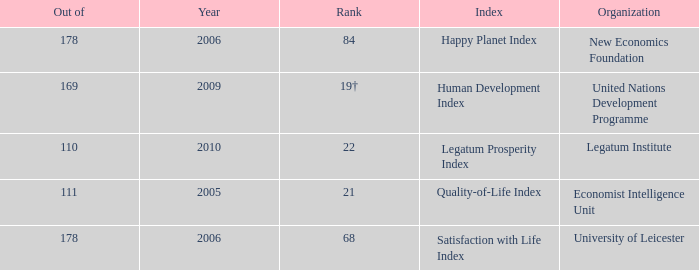What year for the legatum institute? 2010.0. 